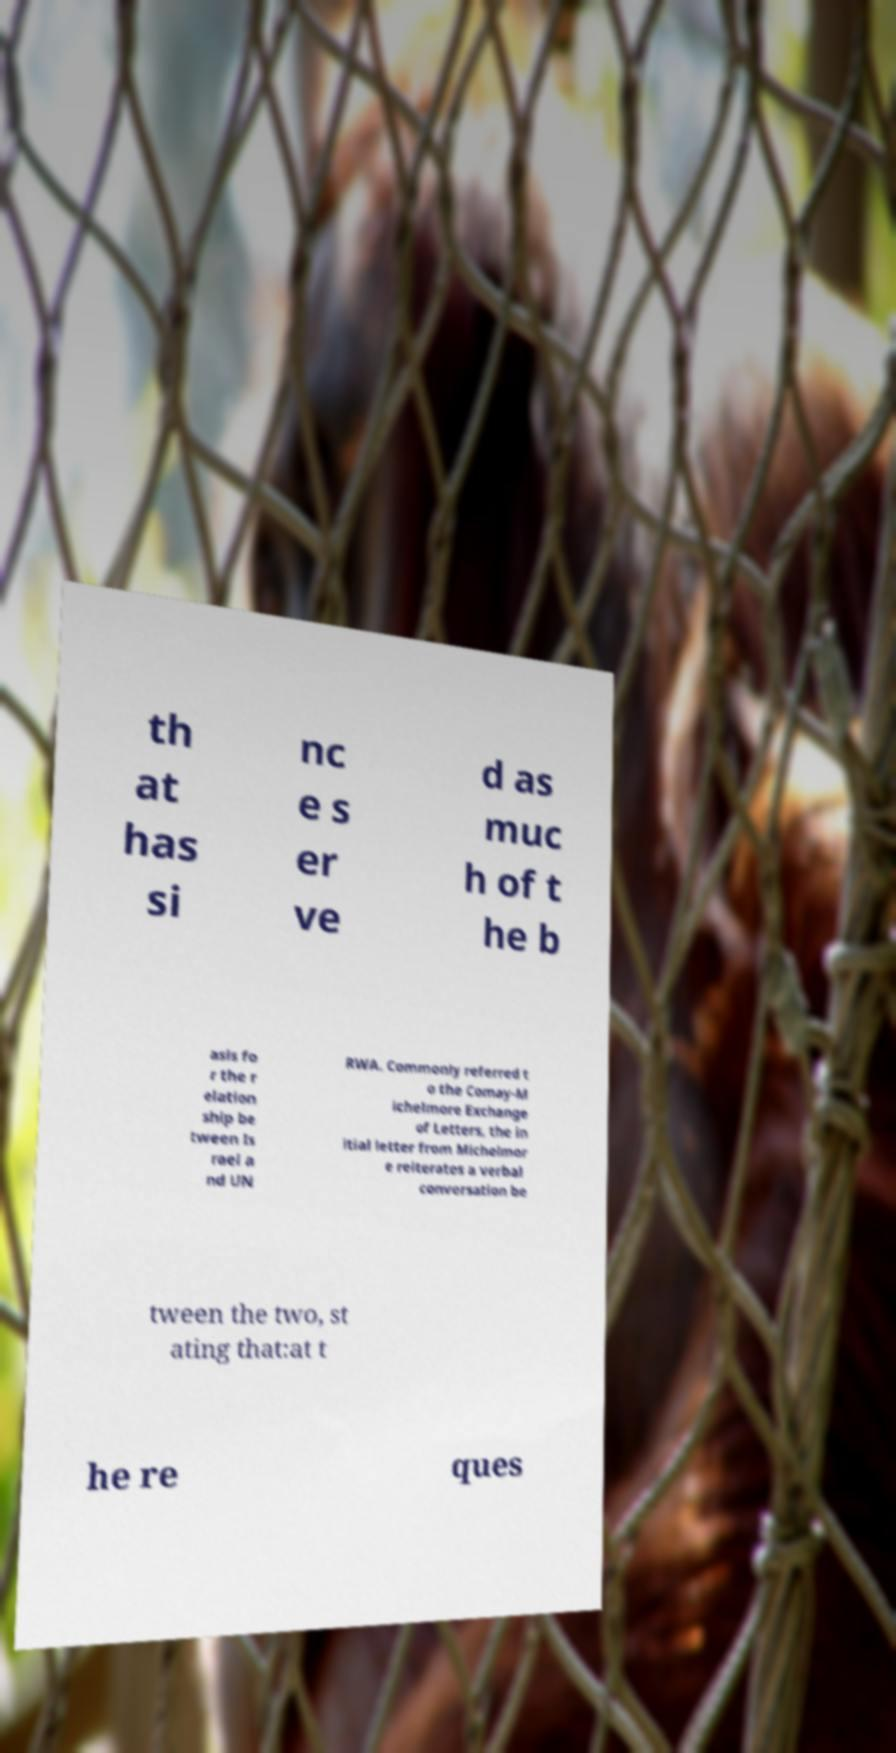Please read and relay the text visible in this image. What does it say? th at has si nc e s er ve d as muc h of t he b asis fo r the r elation ship be tween Is rael a nd UN RWA. Commonly referred t o the Comay-M ichelmore Exchange of Letters, the in itial letter from Michelmor e reiterates a verbal conversation be tween the two, st ating that:at t he re ques 